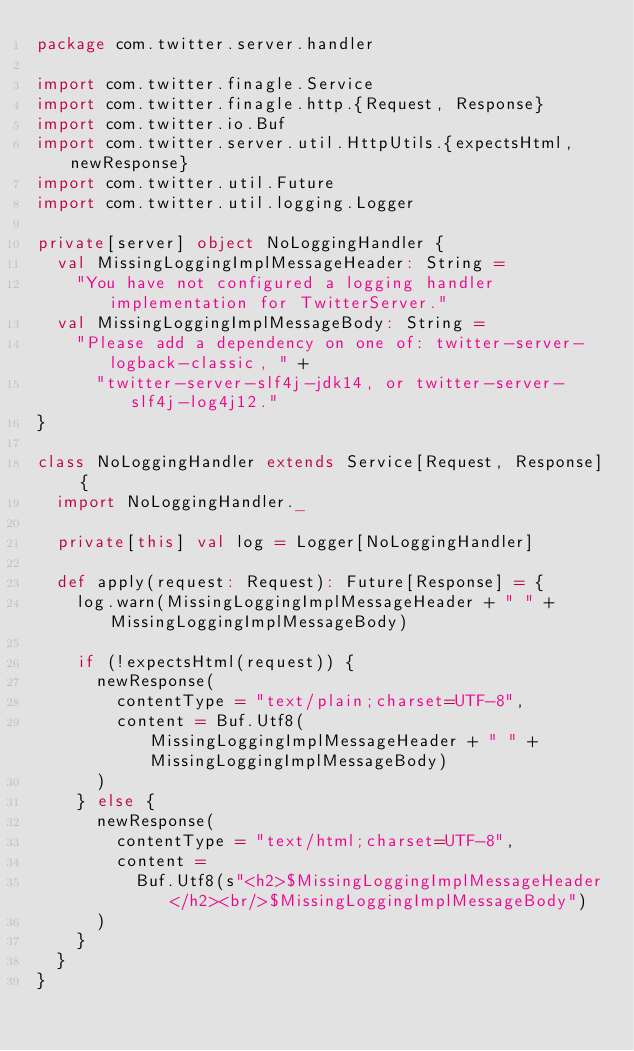Convert code to text. <code><loc_0><loc_0><loc_500><loc_500><_Scala_>package com.twitter.server.handler

import com.twitter.finagle.Service
import com.twitter.finagle.http.{Request, Response}
import com.twitter.io.Buf
import com.twitter.server.util.HttpUtils.{expectsHtml, newResponse}
import com.twitter.util.Future
import com.twitter.util.logging.Logger

private[server] object NoLoggingHandler {
  val MissingLoggingImplMessageHeader: String =
    "You have not configured a logging handler implementation for TwitterServer."
  val MissingLoggingImplMessageBody: String =
    "Please add a dependency on one of: twitter-server-logback-classic, " +
      "twitter-server-slf4j-jdk14, or twitter-server-slf4j-log4j12."
}

class NoLoggingHandler extends Service[Request, Response] {
  import NoLoggingHandler._

  private[this] val log = Logger[NoLoggingHandler]

  def apply(request: Request): Future[Response] = {
    log.warn(MissingLoggingImplMessageHeader + " " + MissingLoggingImplMessageBody)

    if (!expectsHtml(request)) {
      newResponse(
        contentType = "text/plain;charset=UTF-8",
        content = Buf.Utf8(MissingLoggingImplMessageHeader + " " + MissingLoggingImplMessageBody)
      )
    } else {
      newResponse(
        contentType = "text/html;charset=UTF-8",
        content =
          Buf.Utf8(s"<h2>$MissingLoggingImplMessageHeader</h2><br/>$MissingLoggingImplMessageBody")
      )
    }
  }
}
</code> 